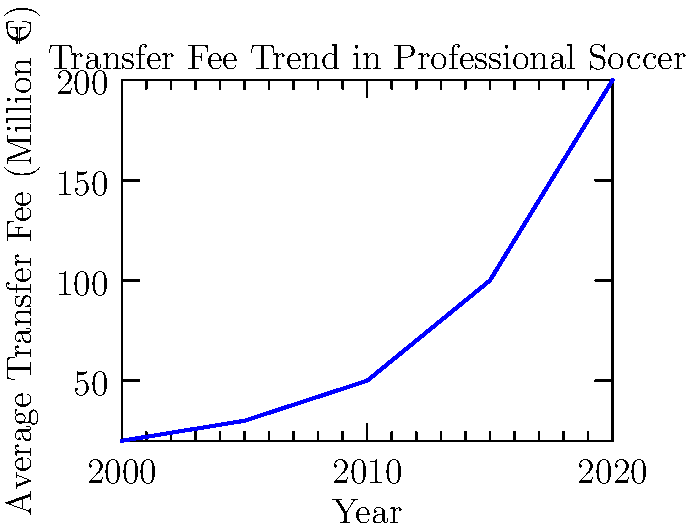Based on the line graph showing the trend of transfer fees in professional soccer from 2000 to 2020, what economic principle best explains the steep increase in fees over time? To answer this question, we need to analyze the graph and apply economic principles:

1. Observe the trend: The graph shows a clear upward trend in transfer fees from 2000 to 2020.

2. Note the acceleration: The increase is not linear but exponential, with a steeper rise after 2010.

3. Consider market forces:
   a) Supply: The number of top-quality players is limited.
   b) Demand: Increased global interest in soccer, more wealthy clubs, and higher stakes in competitions.

4. Apply economic theory: The steep increase can be explained by the law of supply and demand. As demand for top players increases while supply remains relatively constant, prices (transfer fees) rise.

5. Consider additional factors:
   a) Increased revenue in soccer (TV rights, sponsorships)
   b) Globalization of the sport
   c) Influx of wealthy owners and investors

6. Conclusion: The principle of supply and demand, a fundamental market force, best explains the trend.
Answer: Supply and demand 